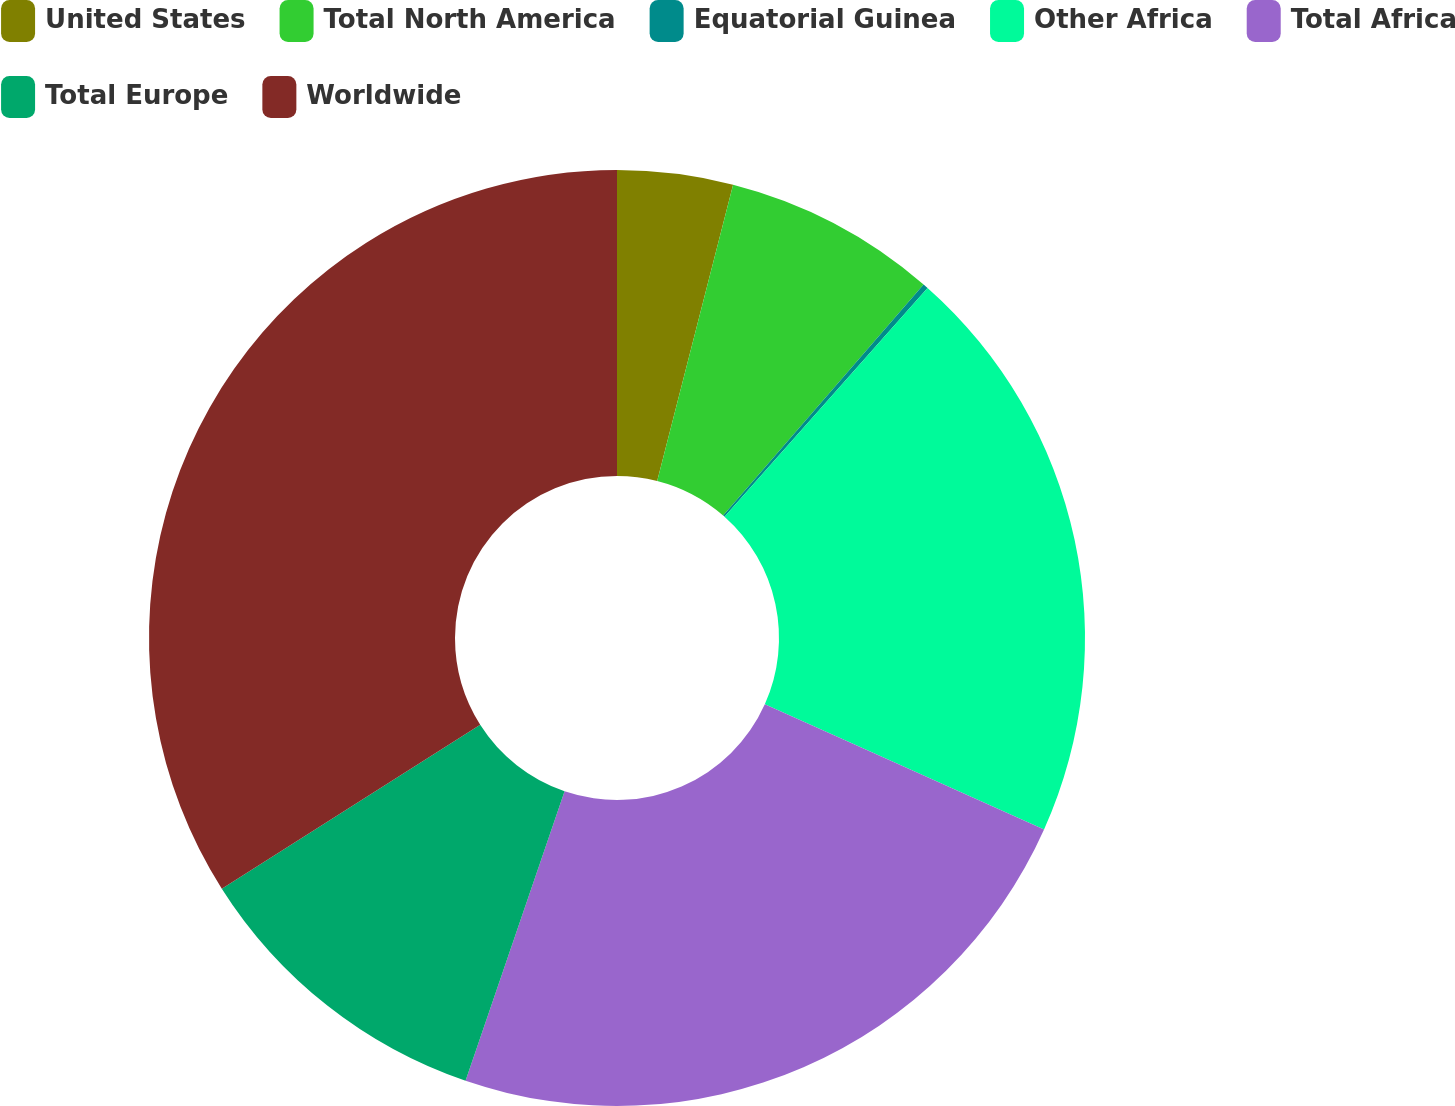<chart> <loc_0><loc_0><loc_500><loc_500><pie_chart><fcel>United States<fcel>Total North America<fcel>Equatorial Guinea<fcel>Other Africa<fcel>Total Africa<fcel>Total Europe<fcel>Worldwide<nl><fcel>3.99%<fcel>7.38%<fcel>0.18%<fcel>20.16%<fcel>23.54%<fcel>10.76%<fcel>34.0%<nl></chart> 